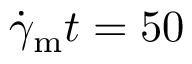<formula> <loc_0><loc_0><loc_500><loc_500>\dot { \gamma } _ { m } t = 5 0</formula> 